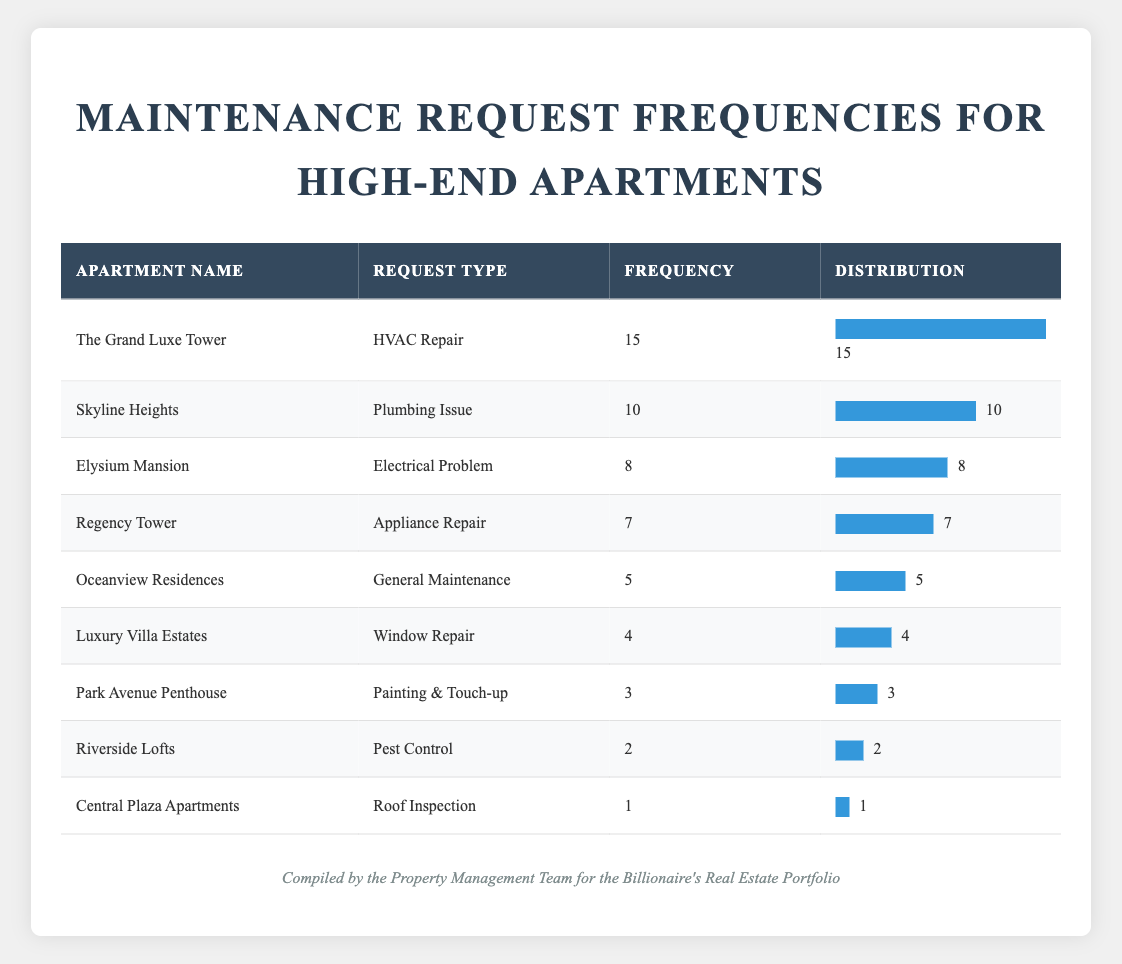What is the most common type of maintenance request? The table shows that "HVAC Repair" for "The Grand Luxe Tower" has the highest frequency of 15 requests, which is more than any other type of maintenance request.
Answer: HVAC Repair How many requests were submitted for appliance repairs? From the table, "Appliance Repair" for "Regency Tower" has a frequency of 7, indicating that there were 7 requests for that type of maintenance.
Answer: 7 Which apartment had the least frequency of maintenance requests? Looking at the table, "Central Plaza Apartments" had a frequency of 1, which is lower than any other apartment listed.
Answer: Central Plaza Apartments What is the total frequency of all maintenance requests? To find the total frequency, we add all the individual frequencies: 15 + 10 + 8 + 7 + 5 + 3 + 2 + 4 + 1 = 55. Thus, the total frequency of maintenance requests is 55.
Answer: 55 Is the frequency of plumbing issues higher than that of pest control requests? From the table, "Plumbing Issue" for "Skyline Heights" has a frequency of 10, while "Pest Control" for "Riverside Lofts" has a frequency of 2. Since 10 is greater than 2, the statement is true.
Answer: Yes Which two apartments combined have a frequency of more than 20 requests? Checking the table, "The Grand Luxe Tower" has 15 and "Skyline Heights" has 10. When combined (15 + 10), they total 25, which is more than 20.
Answer: The Grand Luxe Tower and Skyline Heights How many types of maintenance requests have a frequency of less than 5? The types of maintenance requests with a frequency of less than 5 are: "Window Repair" (4), "Painting & Touch-up" (3), "Pest Control" (2), and "Roof Inspection" (1). This totals 4 types of requests.
Answer: 4 What is the average frequency of maintenance requests across all apartments? To calculate the average, we take the total frequency (55) and divide it by the number of requests (9): 55 / 9 = 6.11 (rounded to two decimal places).
Answer: 6.11 Which apartment had a frequency that is exactly twice that of "Central Plaza Apartments"? "Luxury Villa Estates" had a frequency of 4 requests, which is exactly twice the frequency of "Central Plaza Apartments," which had 1 request.
Answer: Luxury Villa Estates 